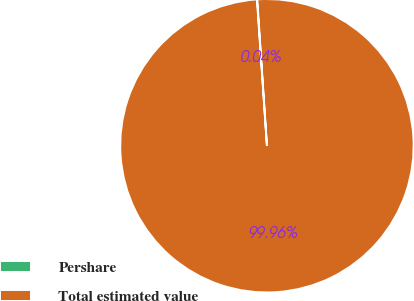Convert chart to OTSL. <chart><loc_0><loc_0><loc_500><loc_500><pie_chart><fcel>Pershare<fcel>Total estimated value<nl><fcel>0.04%<fcel>99.96%<nl></chart> 